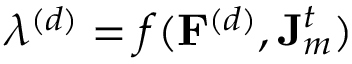<formula> <loc_0><loc_0><loc_500><loc_500>\lambda ^ { ( d ) } = f ( F ^ { ( d ) } , J _ { m } ^ { t } )</formula> 